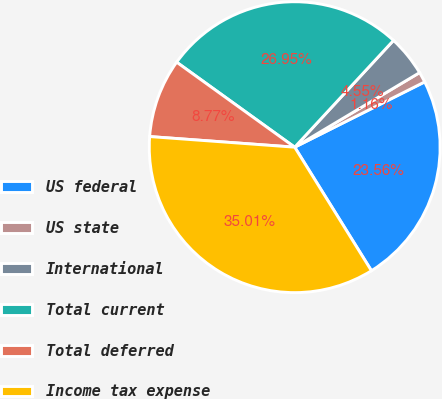<chart> <loc_0><loc_0><loc_500><loc_500><pie_chart><fcel>US federal<fcel>US state<fcel>International<fcel>Total current<fcel>Total deferred<fcel>Income tax expense<nl><fcel>23.56%<fcel>1.16%<fcel>4.55%<fcel>26.95%<fcel>8.77%<fcel>35.01%<nl></chart> 